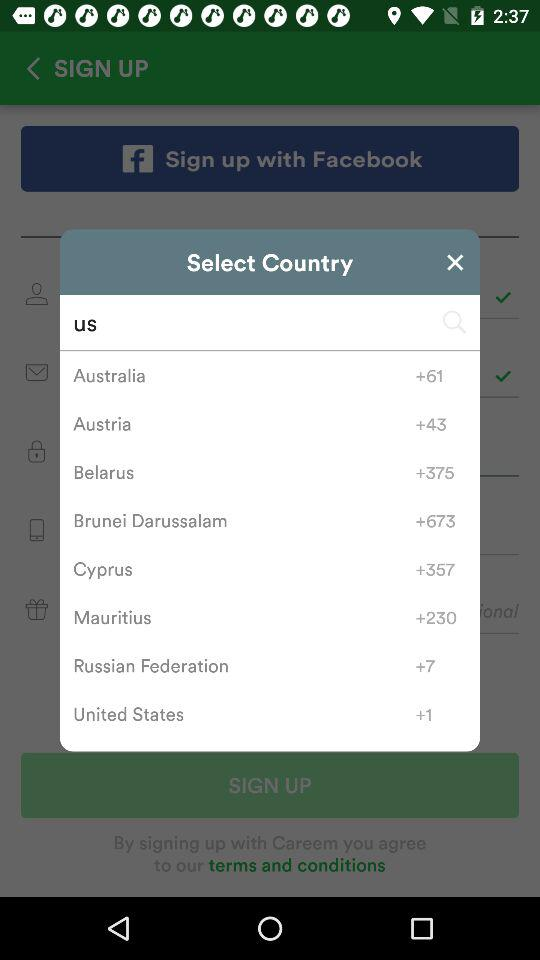How many countries have a country code of +1?
Answer the question using a single word or phrase. 1 